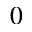Convert formula to latex. <formula><loc_0><loc_0><loc_500><loc_500>0</formula> 